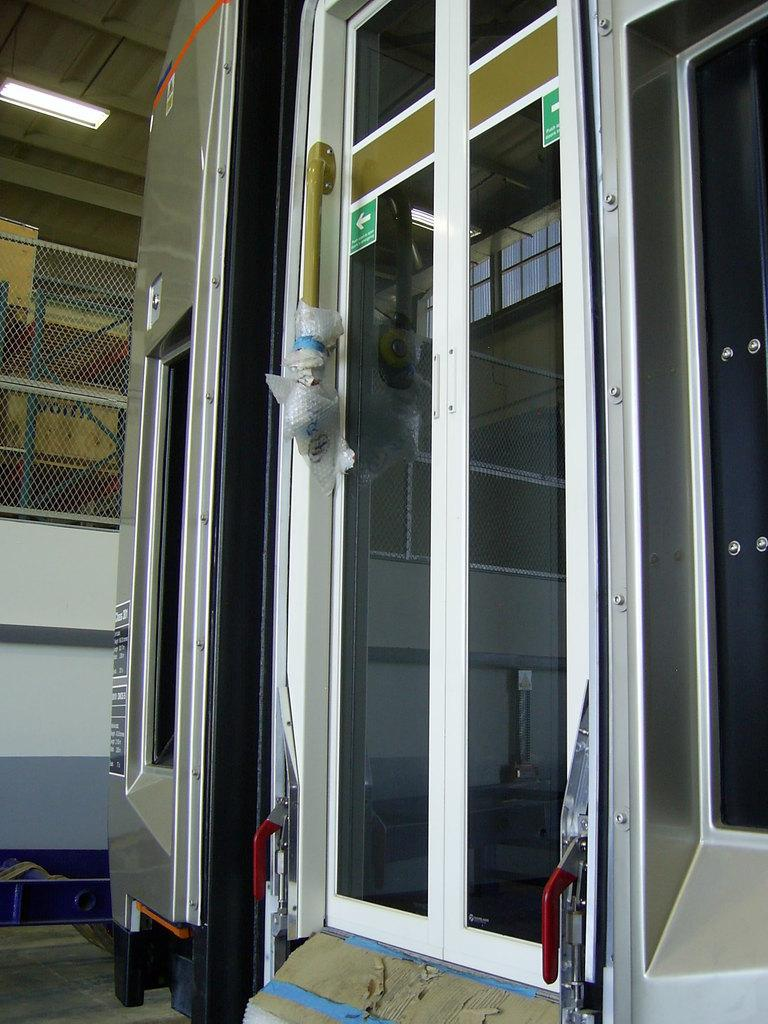What is the main subject in the center of the image? There is a door in the center of the image. What can be seen in the background of the image? There is fencing in the background of the image. What is visible at the bottom of the image? There is a floor visible at the bottom of the image. What type of wound can be seen on the door in the image? There is no wound present on the door in the image. What historical event is depicted in the image? The image does not depict any historical event; it simply shows a door, fencing, and a floor. 